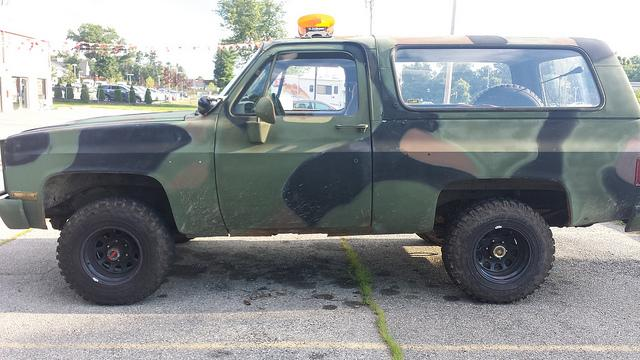What style of paint is on this vehicle?

Choices:
A) graffiti
B) spray
C) watercolor
D) camo camo 